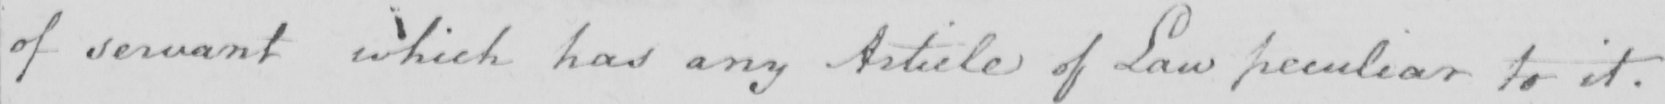Transcribe the text shown in this historical manuscript line. of servant which has any Article of Law peculiar to it . 